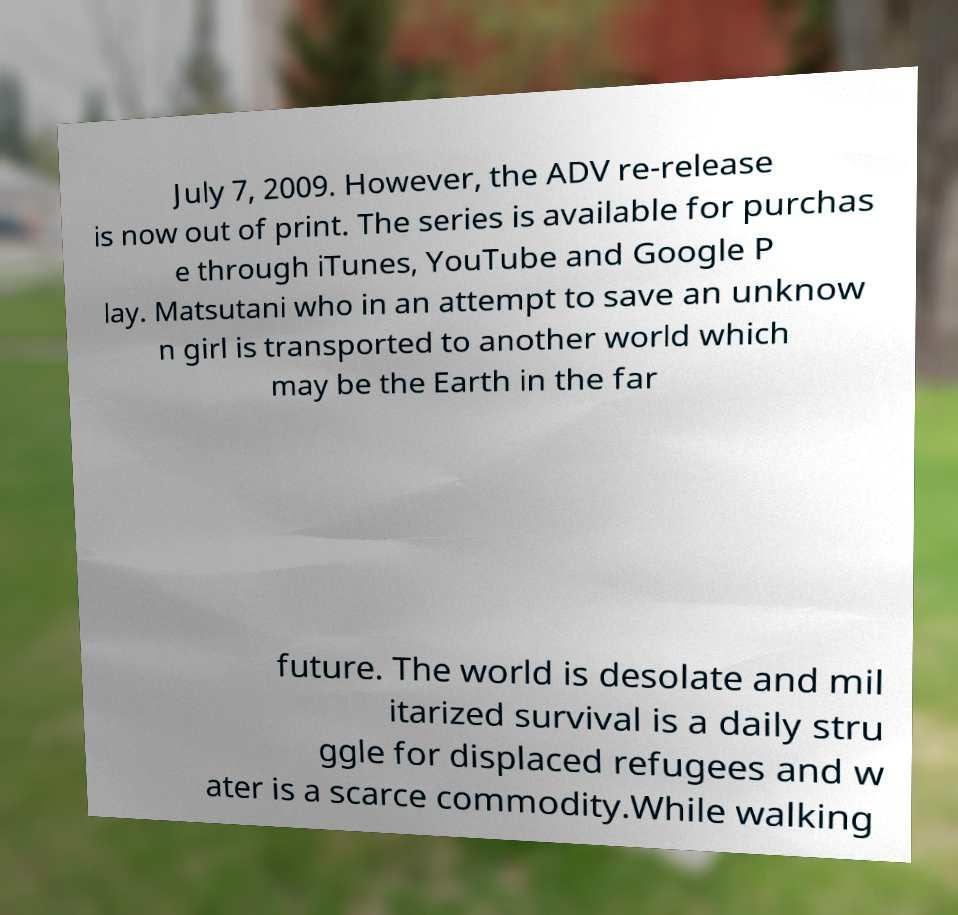There's text embedded in this image that I need extracted. Can you transcribe it verbatim? July 7, 2009. However, the ADV re-release is now out of print. The series is available for purchas e through iTunes, YouTube and Google P lay. Matsutani who in an attempt to save an unknow n girl is transported to another world which may be the Earth in the far future. The world is desolate and mil itarized survival is a daily stru ggle for displaced refugees and w ater is a scarce commodity.While walking 